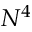Convert formula to latex. <formula><loc_0><loc_0><loc_500><loc_500>N ^ { 4 }</formula> 